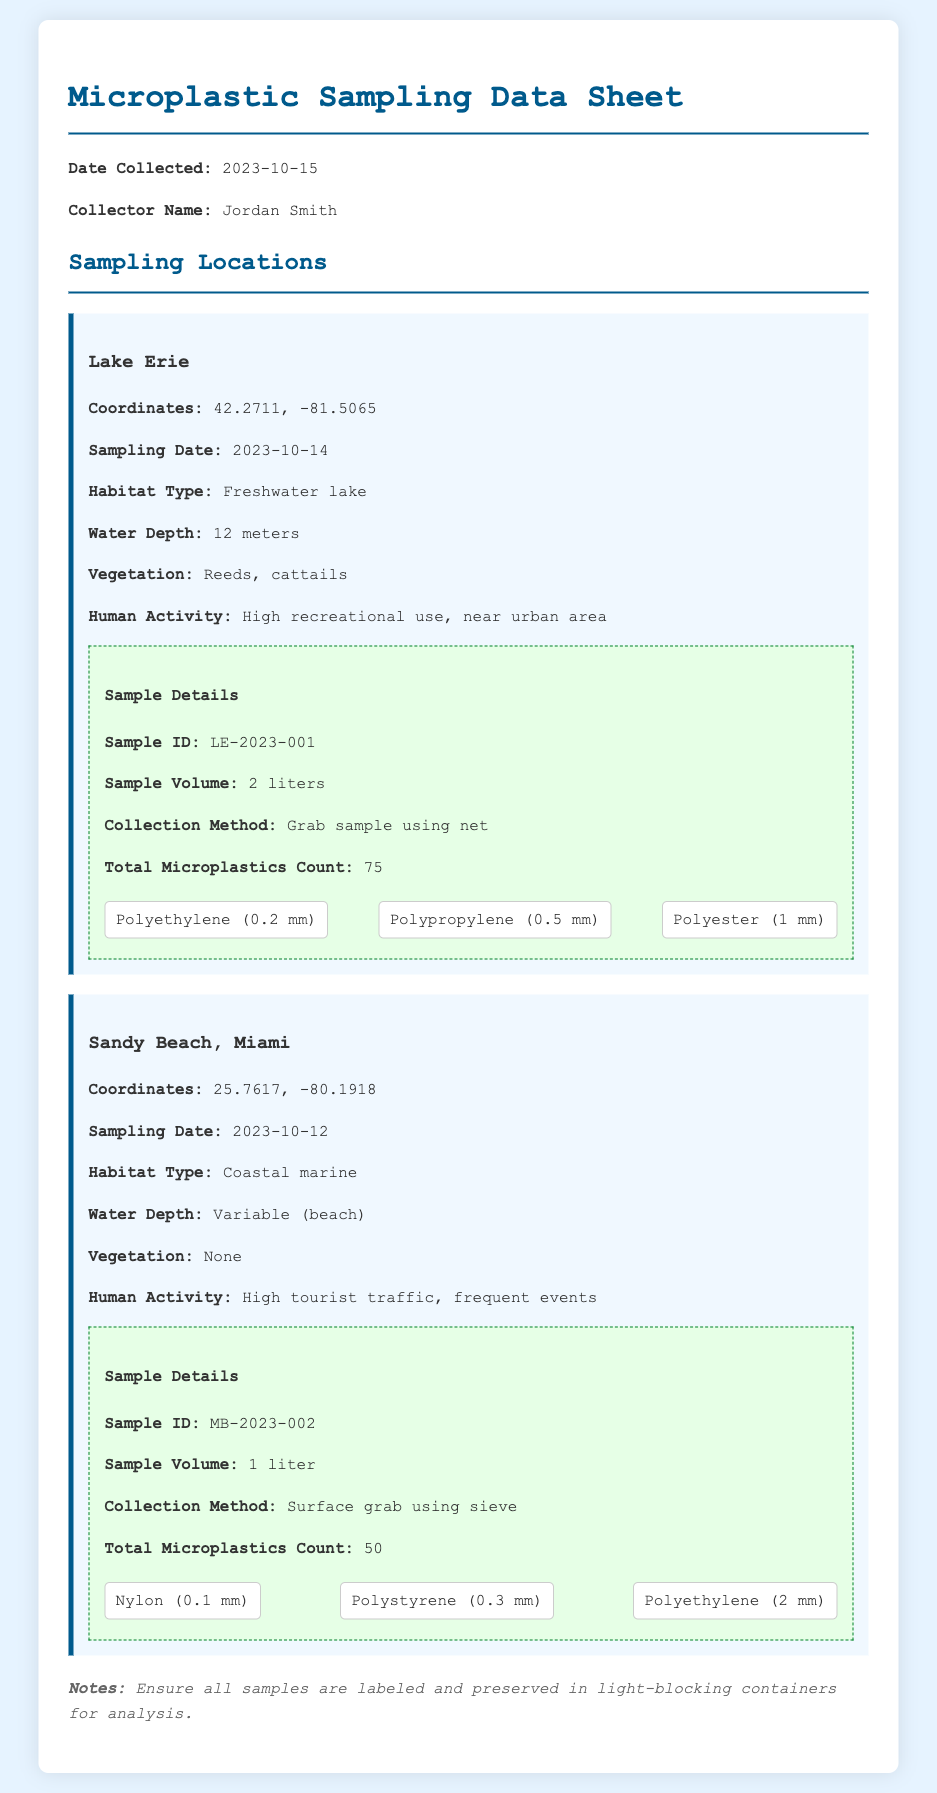what is the collector's name? The collector's name is mentioned at the beginning of the document.
Answer: Jordan Smith when was the sample from Lake Erie collected? The sampling date for Lake Erie is specified in the location section.
Answer: 2023-10-14 how deep is the water at Lake Erie? The water depth for Lake Erie is noted in the habitat details.
Answer: 12 meters what is the total microplastics count for the Sandy Beach sample? The total microplastics count is noted in the sample details for Sandy Beach.
Answer: 50 which sampling location has high recreational use? The document specifies human activity in different locations, including recreational use.
Answer: Lake Erie what types of microplastics were found in the Lake Erie sample? The document lists the various microplastics identified in the sample details section for Lake Erie.
Answer: Polyethylene, Polypropylene, Polyester how many liters is the sample volume from Sandy Beach? The sample volume for Sandy Beach is mentioned in the sample details.
Answer: 1 liter what is the habitat type for Sandy Beach? The habitat type is specified in the sampling location details for Sandy Beach.
Answer: Coastal marine 